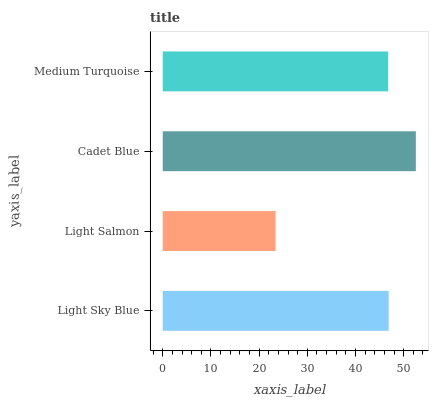Is Light Salmon the minimum?
Answer yes or no. Yes. Is Cadet Blue the maximum?
Answer yes or no. Yes. Is Cadet Blue the minimum?
Answer yes or no. No. Is Light Salmon the maximum?
Answer yes or no. No. Is Cadet Blue greater than Light Salmon?
Answer yes or no. Yes. Is Light Salmon less than Cadet Blue?
Answer yes or no. Yes. Is Light Salmon greater than Cadet Blue?
Answer yes or no. No. Is Cadet Blue less than Light Salmon?
Answer yes or no. No. Is Light Sky Blue the high median?
Answer yes or no. Yes. Is Medium Turquoise the low median?
Answer yes or no. Yes. Is Medium Turquoise the high median?
Answer yes or no. No. Is Light Sky Blue the low median?
Answer yes or no. No. 